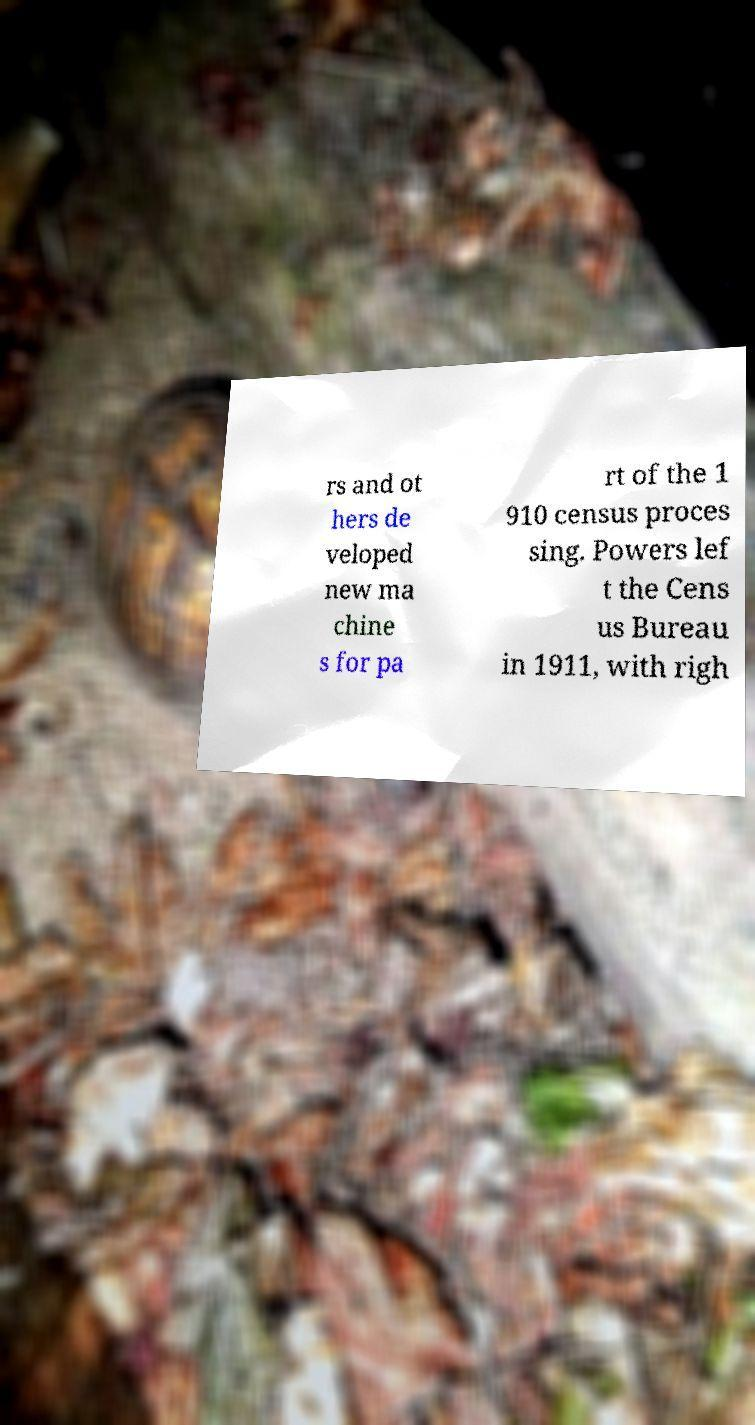Could you extract and type out the text from this image? rs and ot hers de veloped new ma chine s for pa rt of the 1 910 census proces sing. Powers lef t the Cens us Bureau in 1911, with righ 